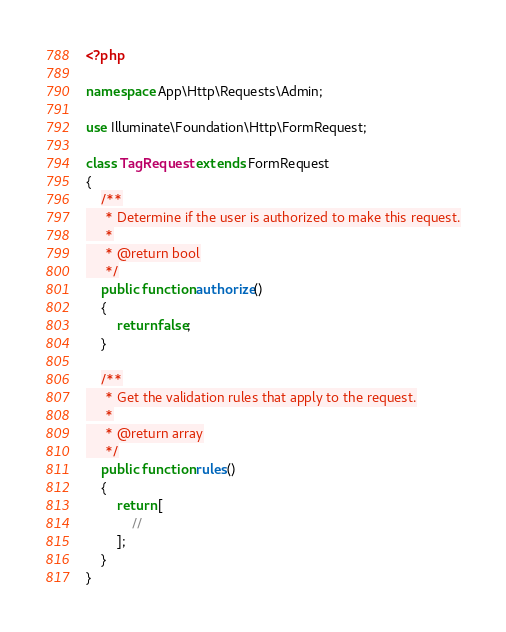Convert code to text. <code><loc_0><loc_0><loc_500><loc_500><_PHP_><?php

namespace App\Http\Requests\Admin;

use Illuminate\Foundation\Http\FormRequest;

class TagRequest extends FormRequest
{
    /**
     * Determine if the user is authorized to make this request.
     *
     * @return bool
     */
    public function authorize()
    {
        return false;
    }

    /**
     * Get the validation rules that apply to the request.
     *
     * @return array
     */
    public function rules()
    {
        return [
            //
        ];
    }
}
</code> 